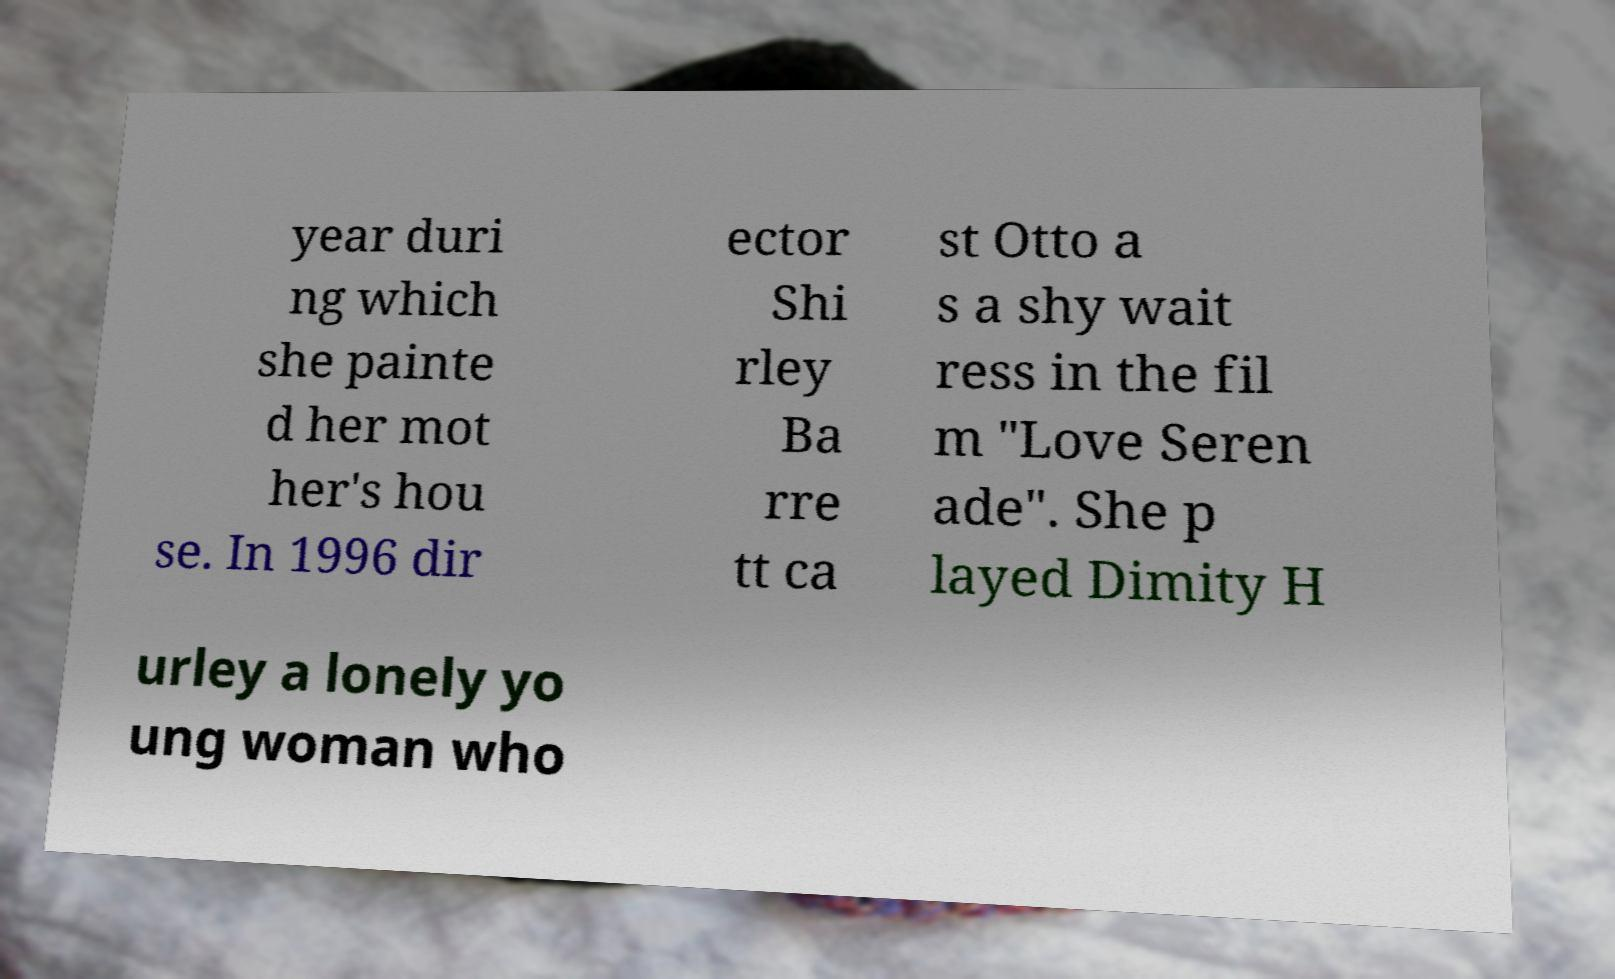There's text embedded in this image that I need extracted. Can you transcribe it verbatim? year duri ng which she painte d her mot her's hou se. In 1996 dir ector Shi rley Ba rre tt ca st Otto a s a shy wait ress in the fil m "Love Seren ade". She p layed Dimity H urley a lonely yo ung woman who 